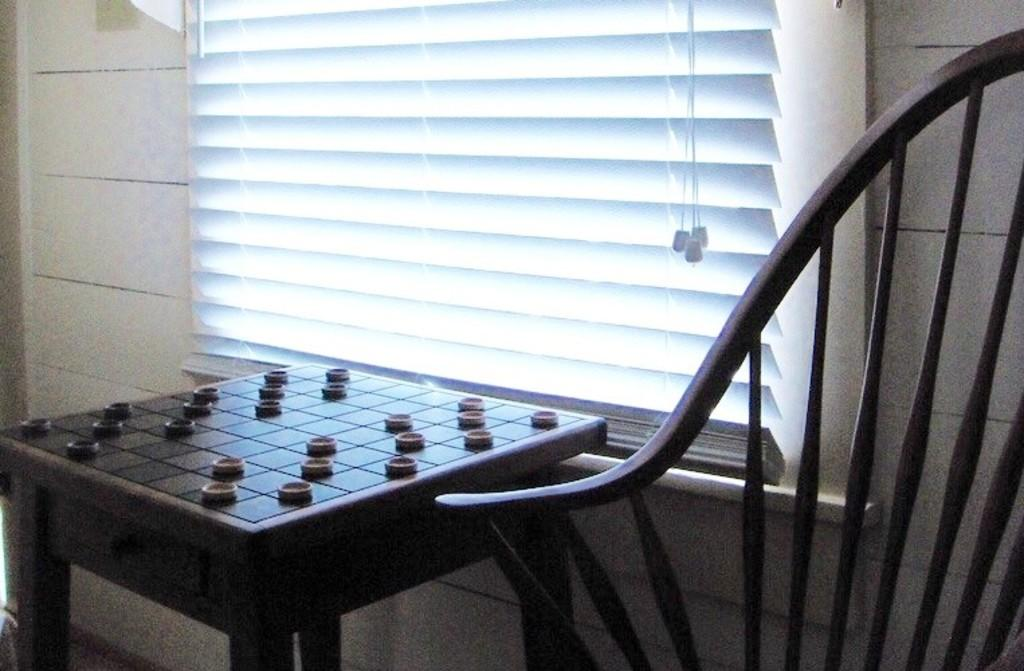What type of furniture is in the image? There is a chair in the image. What object is placed on the chair? A board is placed on the chair. What small objects can be seen in the image? Coins are visible in the image. What is the background of the image? There is a wall in the image. What type of window covering is present in the image? Window blinds are present in the image. What color is the brass balloon in the image? There is no brass balloon present in the image. What rule is being enforced by the chair in the image? The chair in the image is not enforcing any rule; it is simply a piece of furniture. 